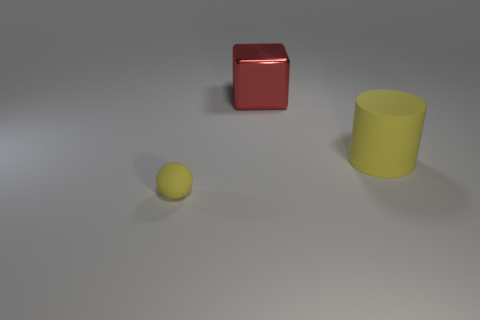Add 1 big red cubes. How many objects exist? 4 Subtract all cylinders. How many objects are left? 2 Add 1 large yellow things. How many large yellow things are left? 2 Add 2 tiny yellow balls. How many tiny yellow balls exist? 3 Subtract 0 gray blocks. How many objects are left? 3 Subtract all small brown metallic spheres. Subtract all tiny balls. How many objects are left? 2 